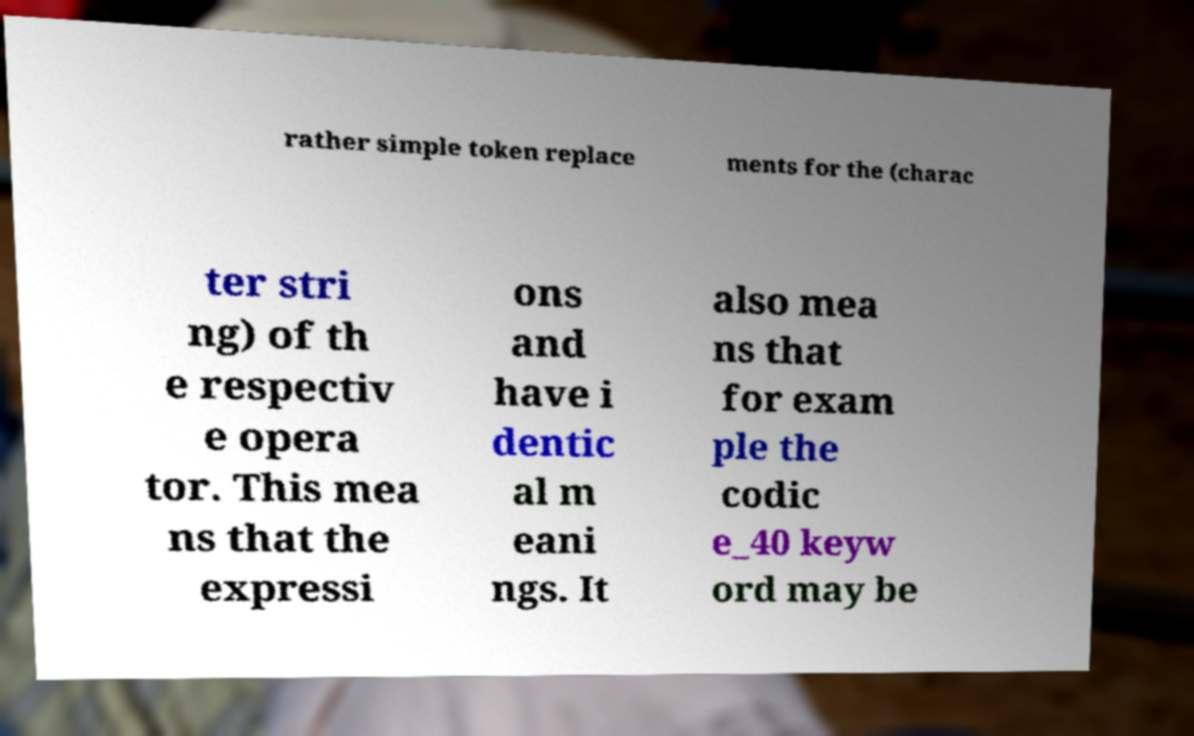There's text embedded in this image that I need extracted. Can you transcribe it verbatim? rather simple token replace ments for the (charac ter stri ng) of th e respectiv e opera tor. This mea ns that the expressi ons and have i dentic al m eani ngs. It also mea ns that for exam ple the codic e_40 keyw ord may be 